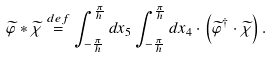<formula> <loc_0><loc_0><loc_500><loc_500>\widetilde { \varphi } * \widetilde { \chi } \stackrel { d e f } { = } \int _ { - \frac { \pi } { h } } ^ { \frac { \pi } { h } } d x _ { 5 } \int _ { - \frac { \pi } { h } } ^ { \frac { \pi } { h } } d x _ { 4 } \cdot \left ( \widetilde { \varphi } ^ { \dagger } \cdot \widetilde { \chi } \right ) .</formula> 